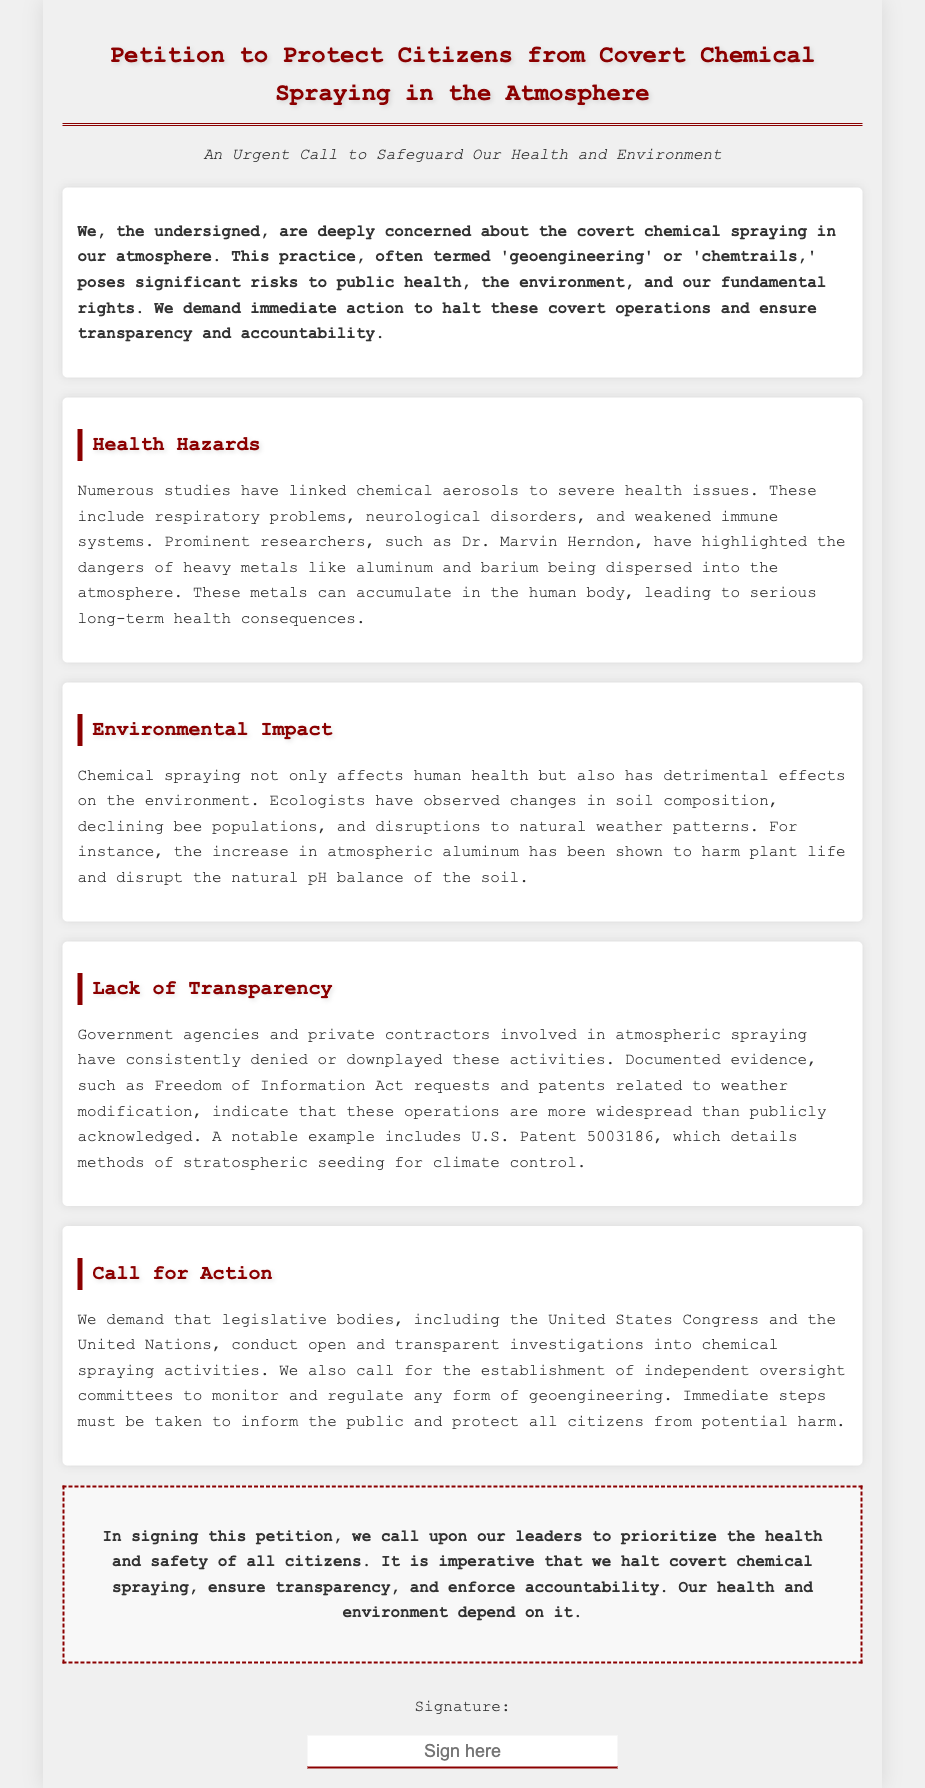What is the title of the petition? The title of the petition is found at the top of the document, prominently displayed.
Answer: Petition to Protect Citizens from Covert Chemical Spraying in the Atmosphere Who is cited as a prominent researcher discussing health hazards? The document names a specific researcher who has highlighted dangers associated with chemical aerosols.
Answer: Dr. Marvin Herndon What is the main demand of the petition? The petition’s focus centers around halting covert chemical spraying and ensuring transparency.
Answer: Halt these covert operations What do chemical aerosols link to, according to the document? The document outlines various severe health issues associated with chemical spraying.
Answer: Respiratory problems, neurological disorders, and weakened immune systems Which environmental change is mentioned in the petition? The petition discusses specific ecological impacts observable by ecologists.
Answer: Declining bee populations What type of investigation does the petition call for? The document emphasizes the need for a certain type of investigation into the activities discussed.
Answer: Open and transparent investigations What is cited as a documented evidence of atmospheric spraying? The document refers to specific requests and patents related to the operations mentioned.
Answer: Freedom of Information Act requests What governing bodies are addressed in the petition? The petition calls the attention of specific legislative bodies for action.
Answer: United States Congress and the United Nations What is the last section of the petition primarily about? The conclusion summarizes the urgent need expressed within the document regarding the main topic.
Answer: Health and safety of all citizens 